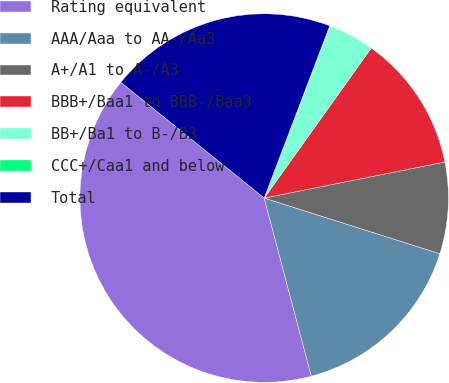Convert chart to OTSL. <chart><loc_0><loc_0><loc_500><loc_500><pie_chart><fcel>Rating equivalent<fcel>AAA/Aaa to AA-/Aa3<fcel>A+/A1 to A-/A3<fcel>BBB+/Baa1 to BBB-/Baa3<fcel>BB+/Ba1 to B-/B3<fcel>CCC+/Caa1 and below<fcel>Total<nl><fcel>39.93%<fcel>16.0%<fcel>8.02%<fcel>12.01%<fcel>4.03%<fcel>0.04%<fcel>19.98%<nl></chart> 